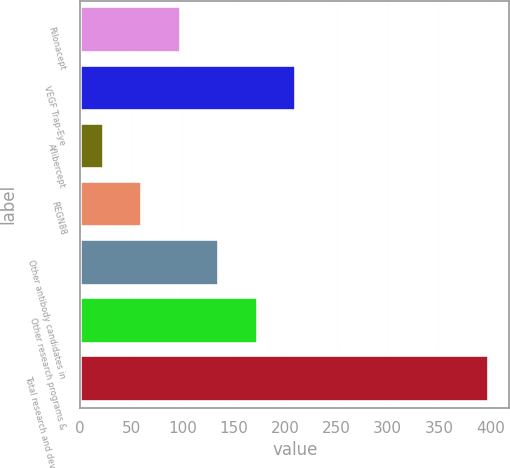Convert chart. <chart><loc_0><loc_0><loc_500><loc_500><bar_chart><fcel>Rilonacept<fcel>VEGF Trap-Eye<fcel>Aflibercept<fcel>REGN88<fcel>Other antibody candidates in<fcel>Other research programs &<fcel>Total research and development<nl><fcel>98.4<fcel>211.05<fcel>23.3<fcel>60.85<fcel>135.95<fcel>173.5<fcel>398.8<nl></chart> 